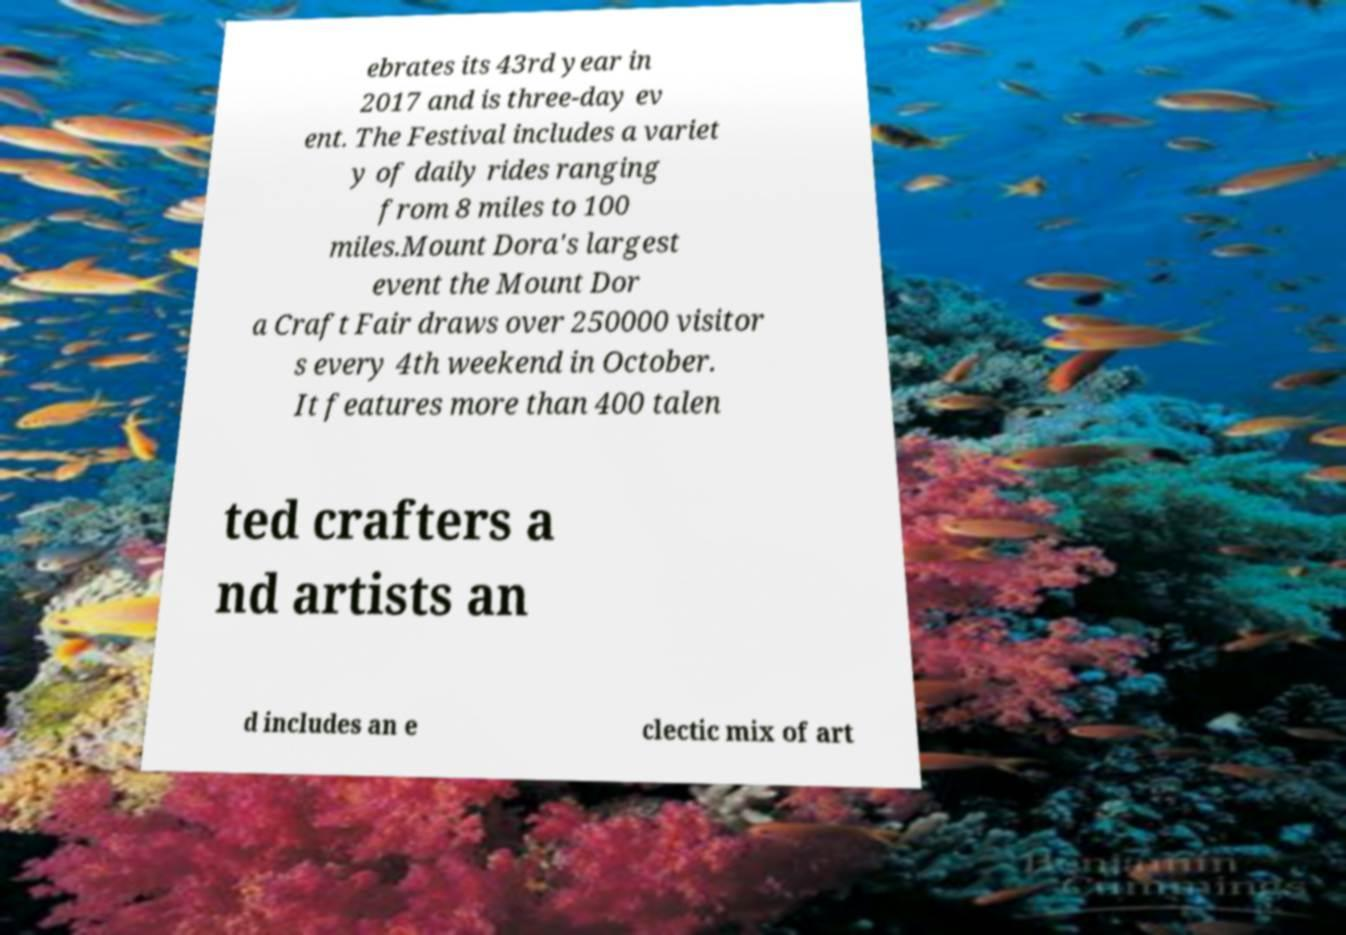Please read and relay the text visible in this image. What does it say? ebrates its 43rd year in 2017 and is three-day ev ent. The Festival includes a variet y of daily rides ranging from 8 miles to 100 miles.Mount Dora's largest event the Mount Dor a Craft Fair draws over 250000 visitor s every 4th weekend in October. It features more than 400 talen ted crafters a nd artists an d includes an e clectic mix of art 